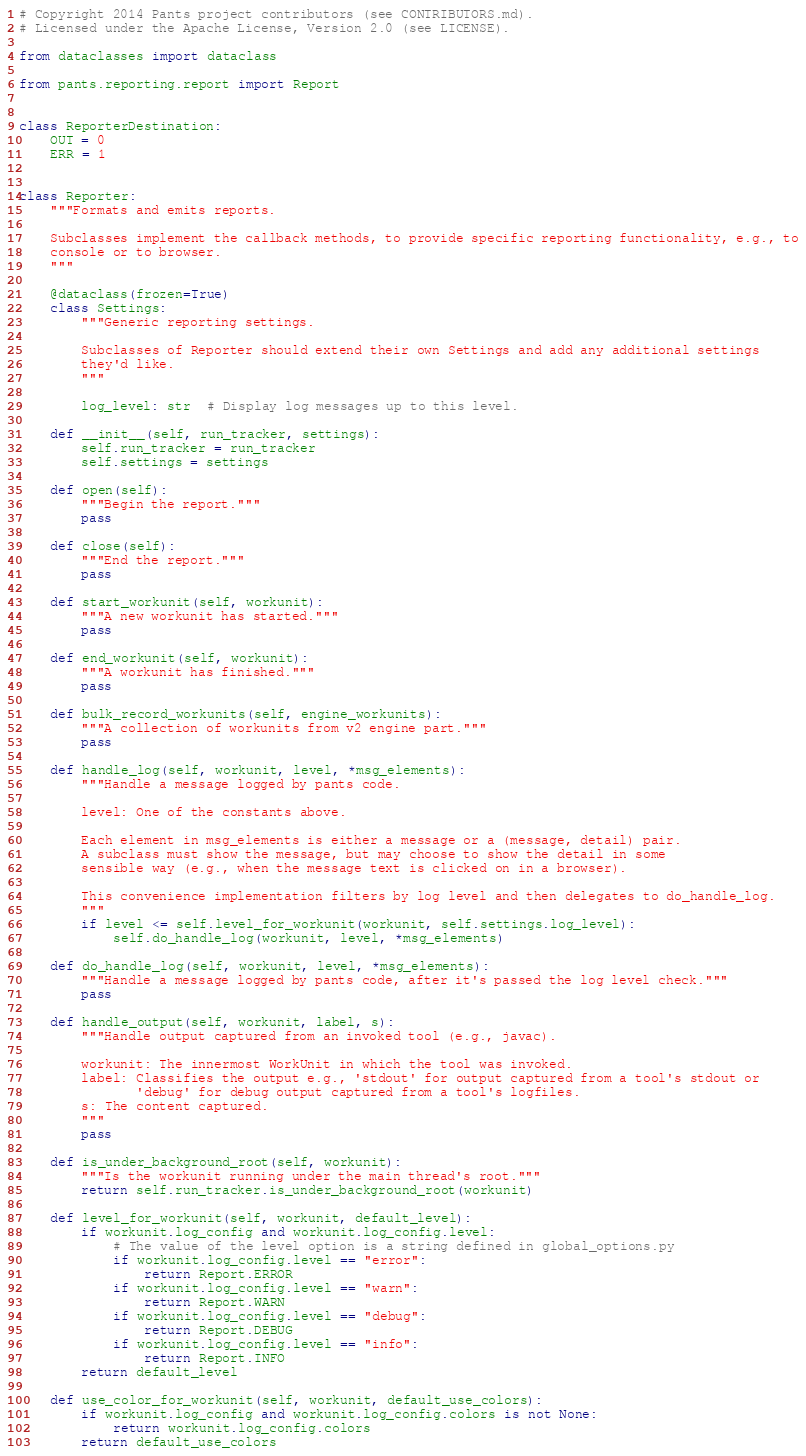Convert code to text. <code><loc_0><loc_0><loc_500><loc_500><_Python_># Copyright 2014 Pants project contributors (see CONTRIBUTORS.md).
# Licensed under the Apache License, Version 2.0 (see LICENSE).

from dataclasses import dataclass

from pants.reporting.report import Report


class ReporterDestination:
    OUT = 0
    ERR = 1


class Reporter:
    """Formats and emits reports.

    Subclasses implement the callback methods, to provide specific reporting functionality, e.g., to
    console or to browser.
    """

    @dataclass(frozen=True)
    class Settings:
        """Generic reporting settings.

        Subclasses of Reporter should extend their own Settings and add any additional settings
        they'd like.
        """

        log_level: str  # Display log messages up to this level.

    def __init__(self, run_tracker, settings):
        self.run_tracker = run_tracker
        self.settings = settings

    def open(self):
        """Begin the report."""
        pass

    def close(self):
        """End the report."""
        pass

    def start_workunit(self, workunit):
        """A new workunit has started."""
        pass

    def end_workunit(self, workunit):
        """A workunit has finished."""
        pass

    def bulk_record_workunits(self, engine_workunits):
        """A collection of workunits from v2 engine part."""
        pass

    def handle_log(self, workunit, level, *msg_elements):
        """Handle a message logged by pants code.

        level: One of the constants above.

        Each element in msg_elements is either a message or a (message, detail) pair.
        A subclass must show the message, but may choose to show the detail in some
        sensible way (e.g., when the message text is clicked on in a browser).

        This convenience implementation filters by log level and then delegates to do_handle_log.
        """
        if level <= self.level_for_workunit(workunit, self.settings.log_level):
            self.do_handle_log(workunit, level, *msg_elements)

    def do_handle_log(self, workunit, level, *msg_elements):
        """Handle a message logged by pants code, after it's passed the log level check."""
        pass

    def handle_output(self, workunit, label, s):
        """Handle output captured from an invoked tool (e.g., javac).

        workunit: The innermost WorkUnit in which the tool was invoked.
        label: Classifies the output e.g., 'stdout' for output captured from a tool's stdout or
               'debug' for debug output captured from a tool's logfiles.
        s: The content captured.
        """
        pass

    def is_under_background_root(self, workunit):
        """Is the workunit running under the main thread's root."""
        return self.run_tracker.is_under_background_root(workunit)

    def level_for_workunit(self, workunit, default_level):
        if workunit.log_config and workunit.log_config.level:
            # The value of the level option is a string defined in global_options.py
            if workunit.log_config.level == "error":
                return Report.ERROR
            if workunit.log_config.level == "warn":
                return Report.WARN
            if workunit.log_config.level == "debug":
                return Report.DEBUG
            if workunit.log_config.level == "info":
                return Report.INFO
        return default_level

    def use_color_for_workunit(self, workunit, default_use_colors):
        if workunit.log_config and workunit.log_config.colors is not None:
            return workunit.log_config.colors
        return default_use_colors
</code> 